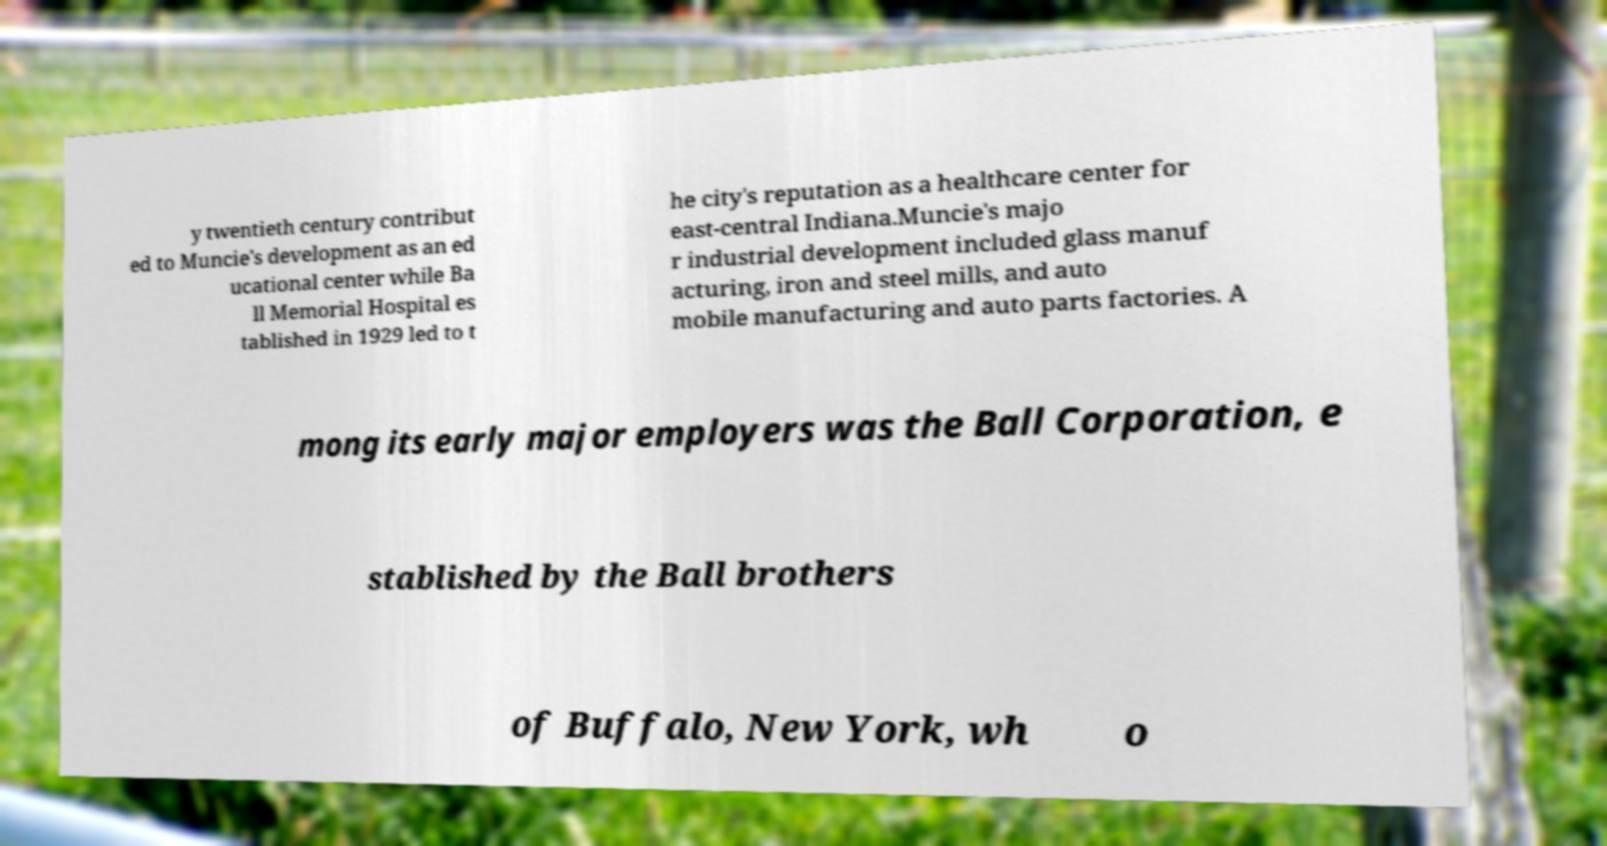Can you accurately transcribe the text from the provided image for me? y twentieth century contribut ed to Muncie's development as an ed ucational center while Ba ll Memorial Hospital es tablished in 1929 led to t he city's reputation as a healthcare center for east-central Indiana.Muncie's majo r industrial development included glass manuf acturing, iron and steel mills, and auto mobile manufacturing and auto parts factories. A mong its early major employers was the Ball Corporation, e stablished by the Ball brothers of Buffalo, New York, wh o 